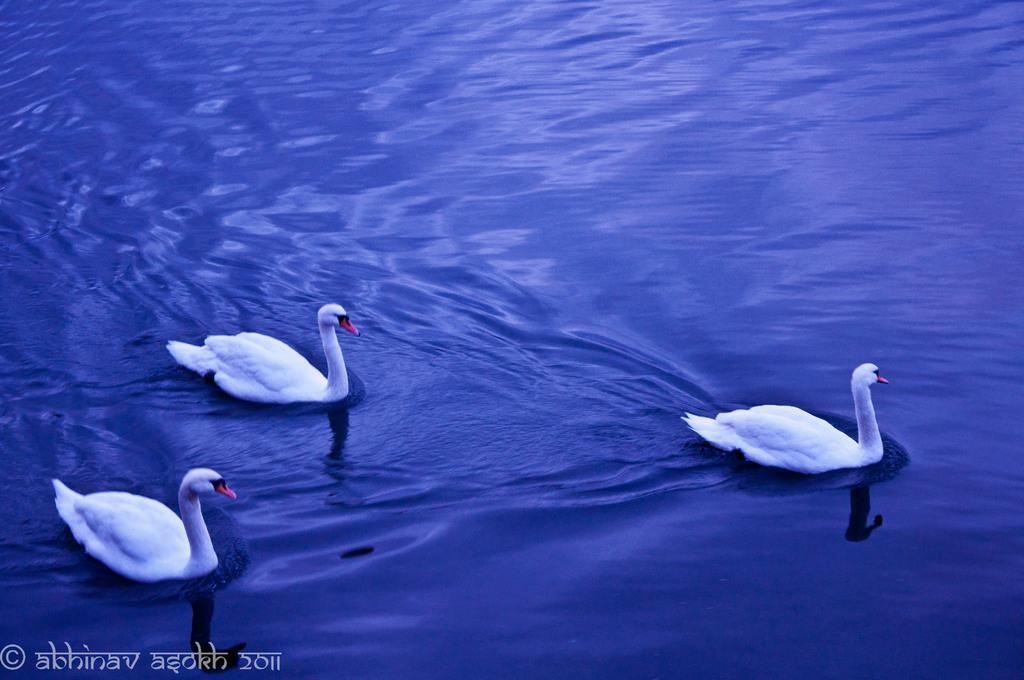Please provide a concise description of this image. In the picture we can see a photograph of the water, which is blue in color in it, we can see three ducks which are white in color. 